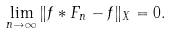Convert formula to latex. <formula><loc_0><loc_0><loc_500><loc_500>\lim _ { n \to \infty } \| f * F _ { n } - f \| _ { X } = 0 .</formula> 